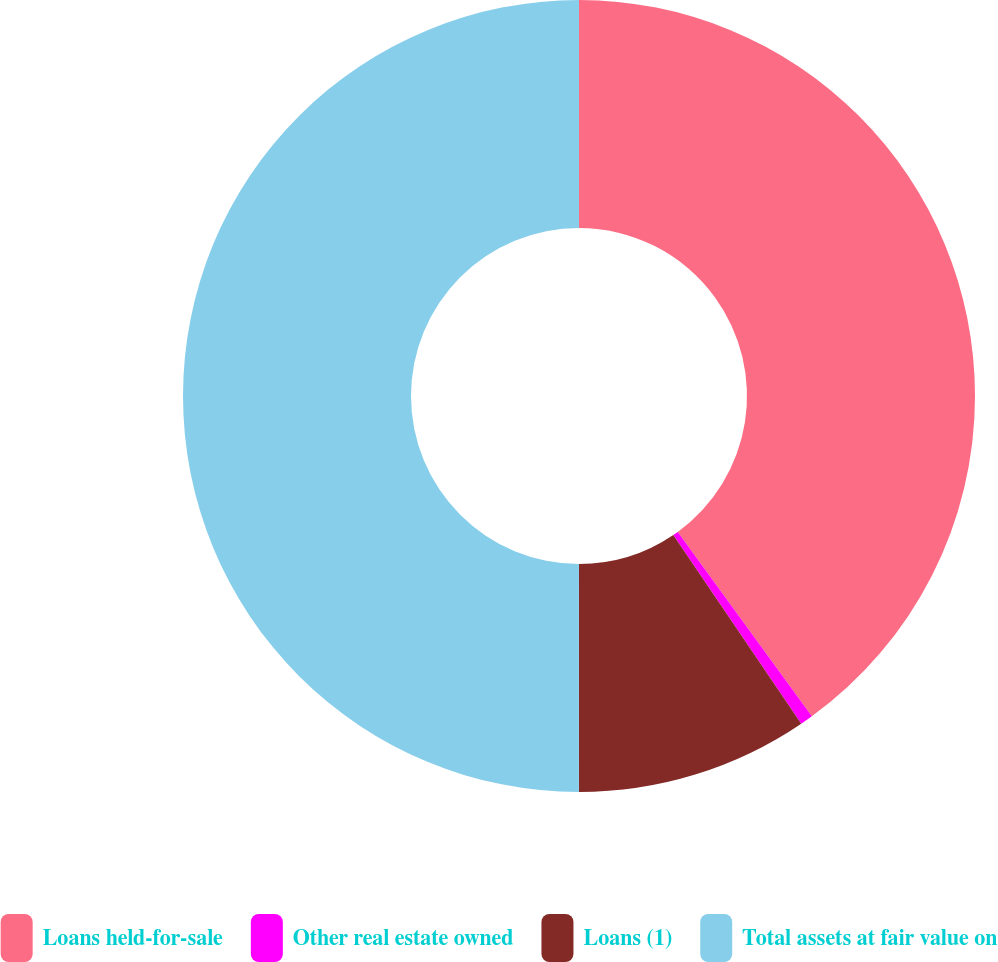<chart> <loc_0><loc_0><loc_500><loc_500><pie_chart><fcel>Loans held-for-sale<fcel>Other real estate owned<fcel>Loans (1)<fcel>Total assets at fair value on<nl><fcel>40.0%<fcel>0.52%<fcel>9.49%<fcel>50.0%<nl></chart> 